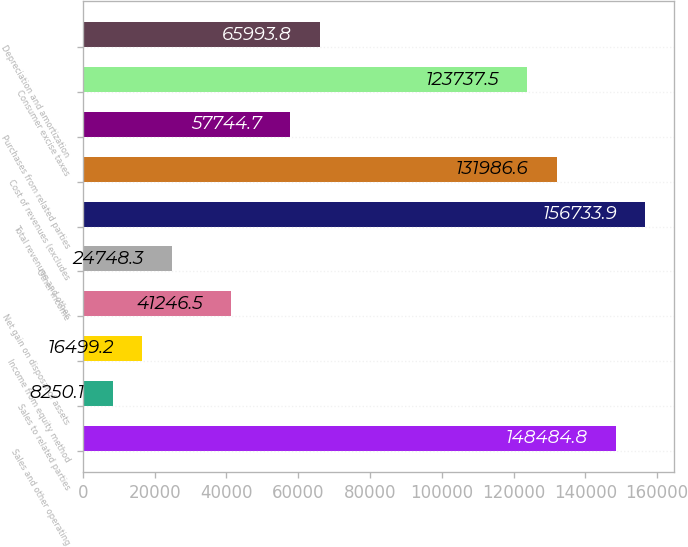Convert chart. <chart><loc_0><loc_0><loc_500><loc_500><bar_chart><fcel>Sales and other operating<fcel>Sales to related parties<fcel>Income from equity method<fcel>Net gain on disposal of assets<fcel>Other income<fcel>Total revenues and other<fcel>Cost of revenues (excludes<fcel>Purchases from related parties<fcel>Consumer excise taxes<fcel>Depreciation and amortization<nl><fcel>148485<fcel>8250.1<fcel>16499.2<fcel>41246.5<fcel>24748.3<fcel>156734<fcel>131987<fcel>57744.7<fcel>123738<fcel>65993.8<nl></chart> 